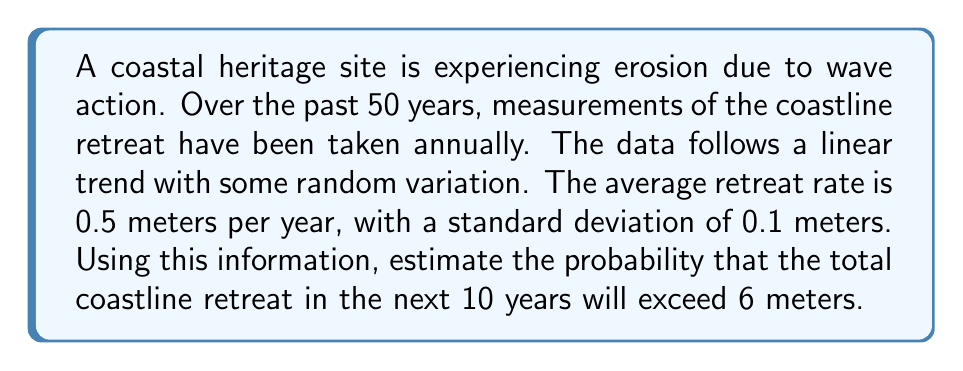Give your solution to this math problem. To solve this problem, we'll use statistical modeling techniques:

1) First, we need to understand the given information:
   - The erosion follows a linear trend with random variation
   - Mean retreat rate (μ) = 0.5 meters/year
   - Standard deviation (σ) = 0.1 meters/year
   - We're looking at a 10-year period
   - We want to find P(X > 6), where X is the total retreat in 10 years

2) For a 10-year period, the expected total retreat is:
   $$ E(X) = 10 * 0.5 = 5 \text{ meters} $$

3) The variance for the 10-year period is:
   $$ Var(X) = 10 * 0.1^2 = 0.1 \text{ meters}^2 $$

4) The standard deviation for the 10-year period is:
   $$ \sigma_X = \sqrt{0.1} \approx 0.3162 \text{ meters} $$

5) We can standardize our variable to use the standard normal distribution:
   $$ Z = \frac{X - \mu}{\sigma} = \frac{6 - 5}{0.3162} \approx 3.1623 $$

6) We want to find P(X > 6), which is equivalent to P(Z > 3.1623)

7) Using a standard normal table or calculator, we can find:
   $$ P(Z > 3.1623) \approx 0.00078 $$

8) Therefore, the probability that the total coastline retreat in the next 10 years will exceed 6 meters is approximately 0.078%.
Answer: 0.00078 (or 0.078%) 